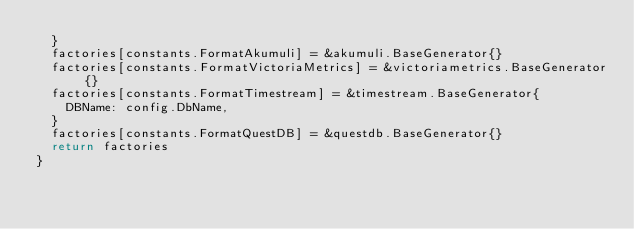<code> <loc_0><loc_0><loc_500><loc_500><_Go_>	}
	factories[constants.FormatAkumuli] = &akumuli.BaseGenerator{}
	factories[constants.FormatVictoriaMetrics] = &victoriametrics.BaseGenerator{}
	factories[constants.FormatTimestream] = &timestream.BaseGenerator{
		DBName: config.DbName,
	}
	factories[constants.FormatQuestDB] = &questdb.BaseGenerator{}
	return factories
}
</code> 